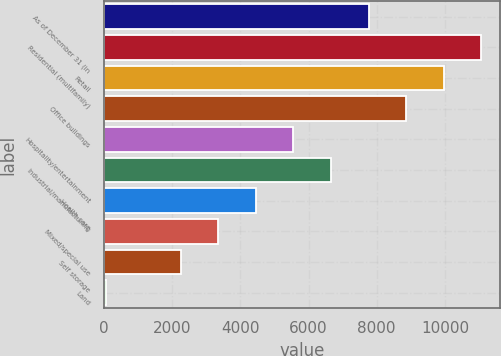Convert chart to OTSL. <chart><loc_0><loc_0><loc_500><loc_500><bar_chart><fcel>As of December 31 (in<fcel>Residential (multifamily)<fcel>Retail<fcel>Office buildings<fcel>Hospitality/entertainment<fcel>Industrial/manufacturing<fcel>Health care<fcel>Mixed/special use<fcel>Self storage<fcel>Land<nl><fcel>7761.29<fcel>11068.7<fcel>9966.23<fcel>8863.76<fcel>5556.35<fcel>6658.82<fcel>4453.88<fcel>3351.41<fcel>2248.94<fcel>44<nl></chart> 